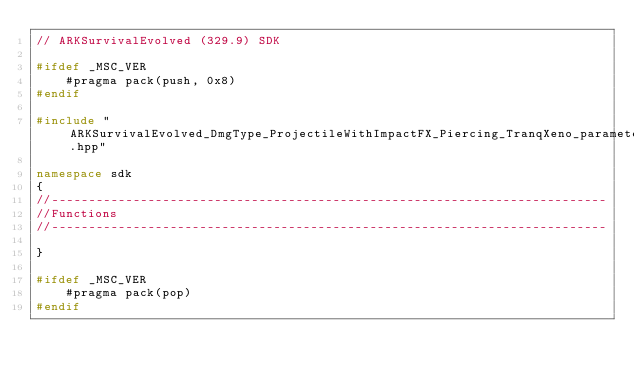<code> <loc_0><loc_0><loc_500><loc_500><_C++_>// ARKSurvivalEvolved (329.9) SDK

#ifdef _MSC_VER
	#pragma pack(push, 0x8)
#endif

#include "ARKSurvivalEvolved_DmgType_ProjectileWithImpactFX_Piercing_TranqXeno_parameters.hpp"

namespace sdk
{
//---------------------------------------------------------------------------
//Functions
//---------------------------------------------------------------------------

}

#ifdef _MSC_VER
	#pragma pack(pop)
#endif
</code> 